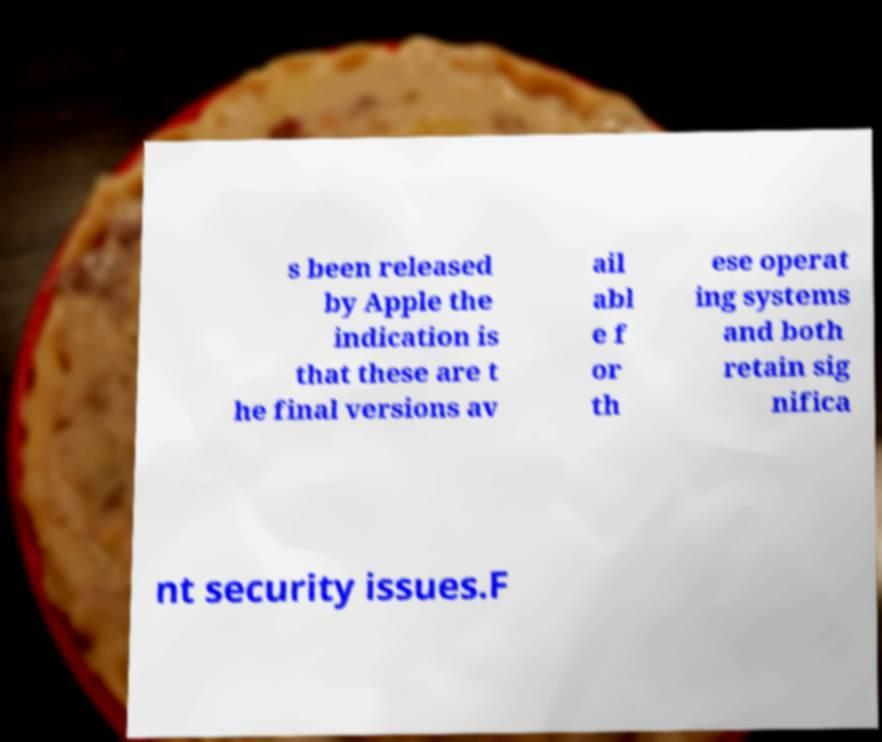I need the written content from this picture converted into text. Can you do that? s been released by Apple the indication is that these are t he final versions av ail abl e f or th ese operat ing systems and both retain sig nifica nt security issues.F 